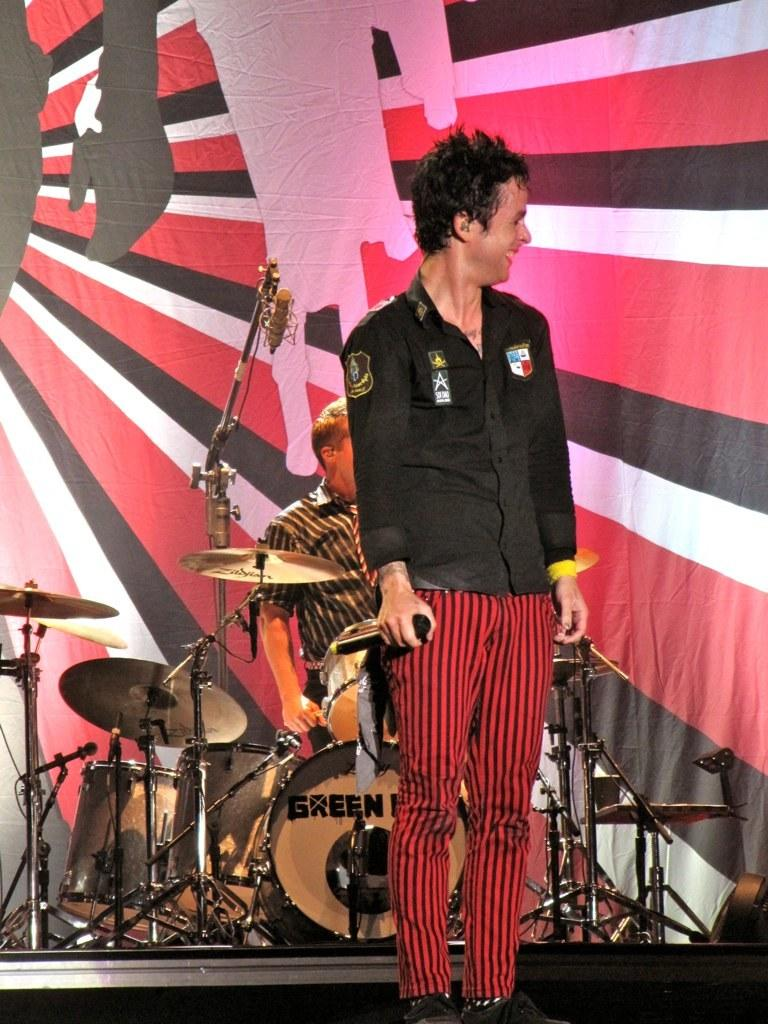What is the man in the image doing? The man is standing in the image and holding a mic in his hand. Can you describe the background of the image? In the background of the image, there is a person, musical instruments, a mic on a stand, and a banner. What might the man be preparing to do with the mic? The man might be preparing to speak or sing into the mic. How many mics are visible in the image? There are two mics visible in the image, one in the man's hand and one on a stand in the background. What shape is the sky in the image? There is no sky visible in the image, so it is not possible to determine its shape. 